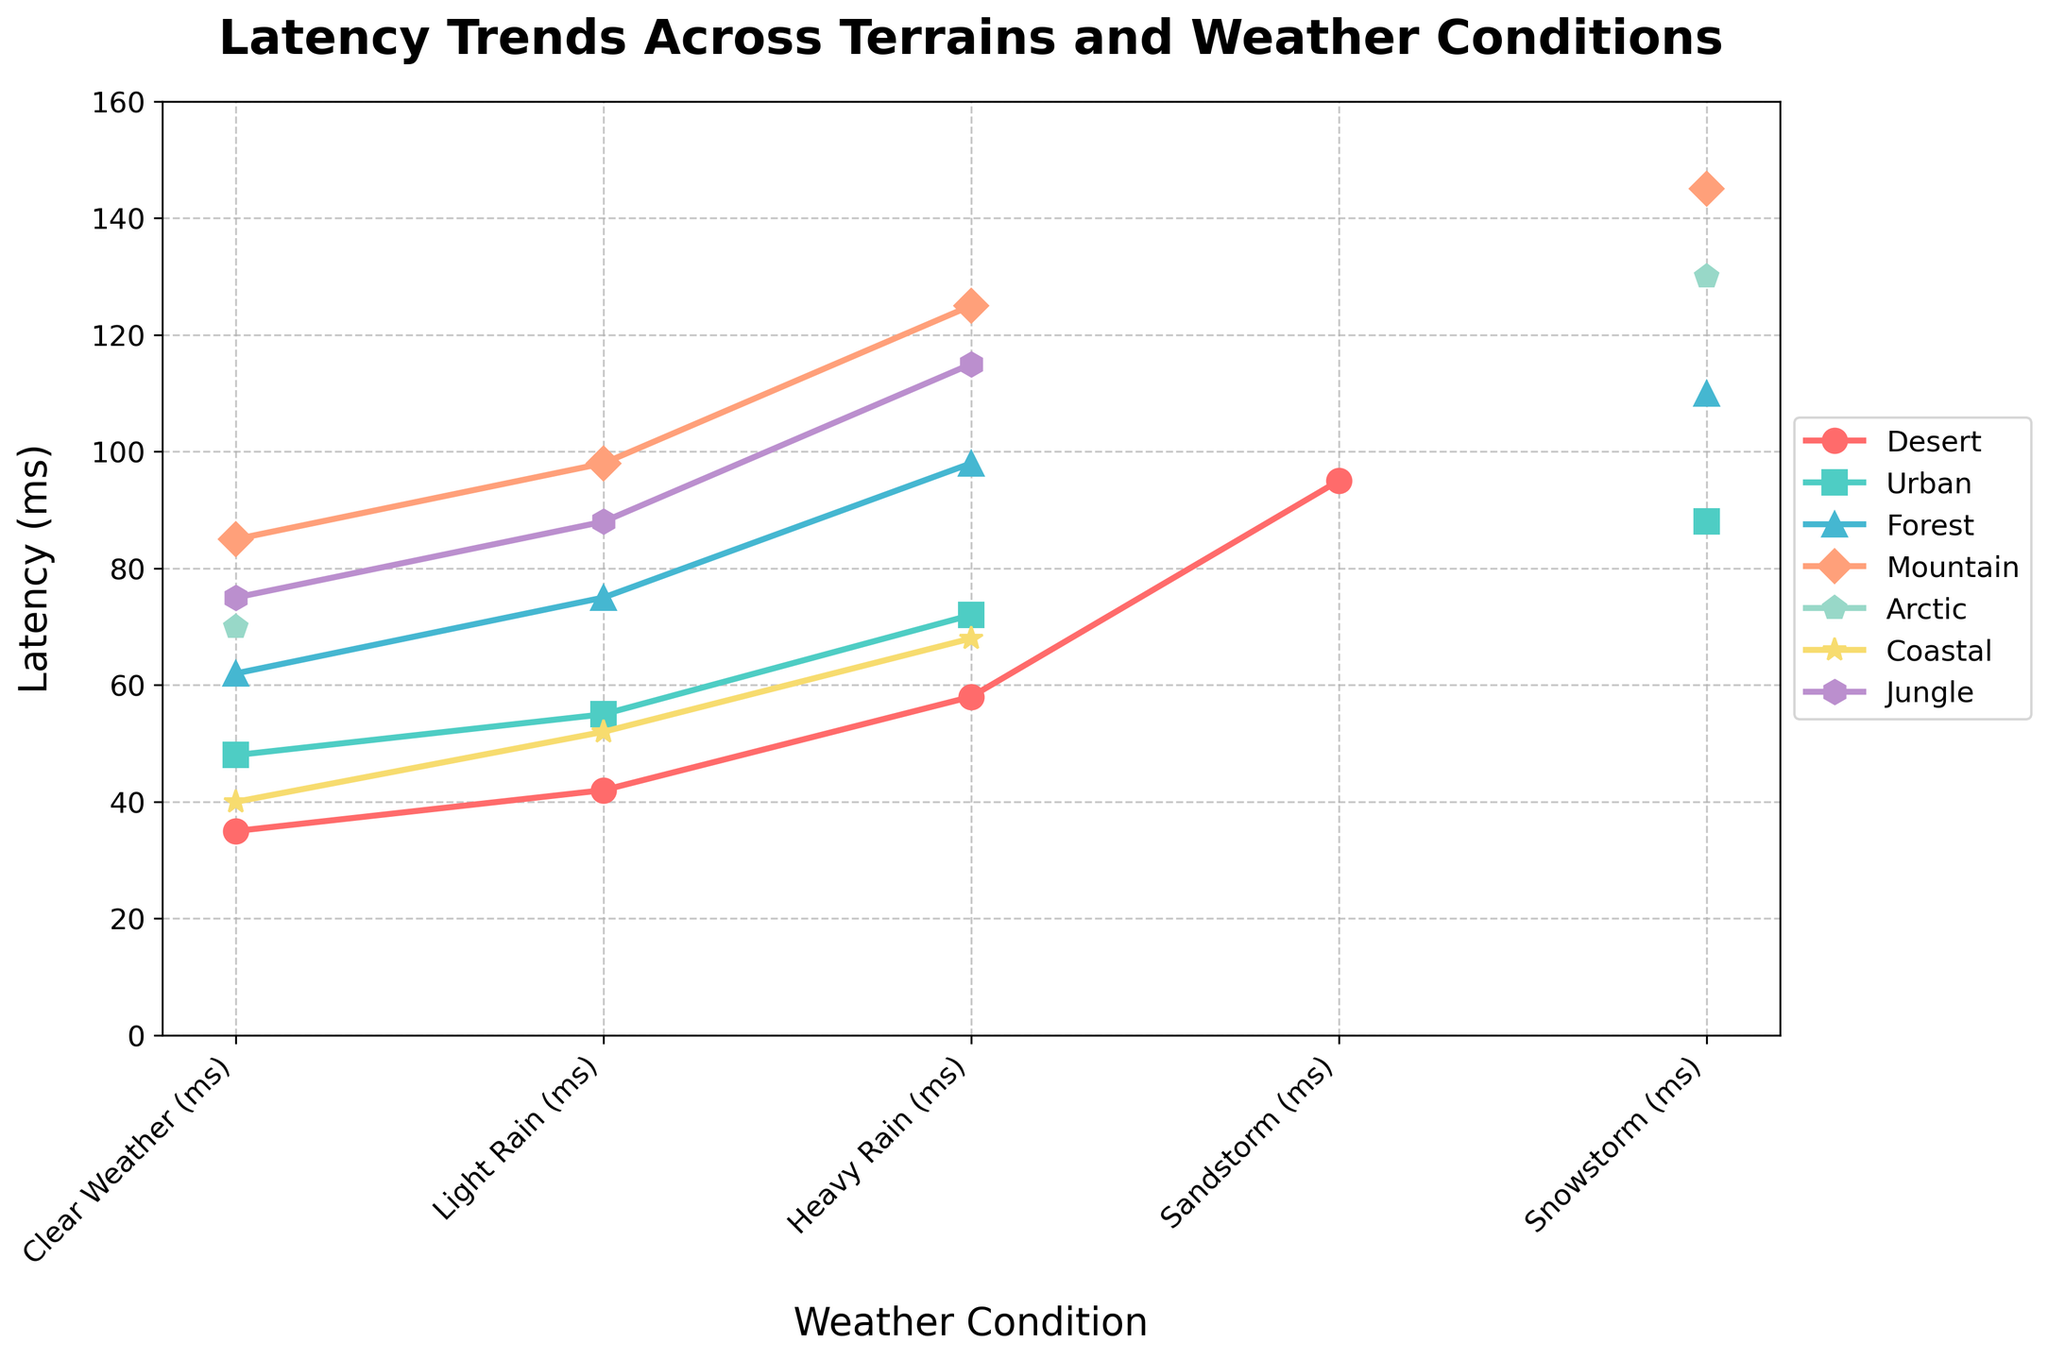What is the average latency for the Arctic terrain across all weather conditions? First, look at the latency values for the Arctic terrain in each weather condition: Clear Weather (70 ms) and Snowstorm (130 ms). Note that 'N/A' values should be excluded. The average latency can be calculated by summing these values (70 + 130 = 200) and then dividing by the number of valid entries (2). Therefore, 200/2 = 100 ms
Answer: 100 ms Which terrain has the highest latency in Clear Weather conditions? Observe the latency values in the Clear Weather column. The values are Desert (35 ms), Urban (48 ms), Forest (62 ms), Mountain (85 ms), Arctic (70 ms), Coastal (40 ms), and Jungle (75 ms). The highest latency is in the Mountain terrain with 85 ms
Answer: Mountain How does the latency in Heavy Rain conditions for Urban compare to that for Forest terrain? The latency for Urban in Heavy Rain is 72 ms, and for Forest, it is 98 ms. By comparing these two values, we see that the latency for Urban in Heavy Rain is less than that for Forest (72 < 98)
Answer: Urban has less latency Which terrain experiences the greatest increase in latency from Clear Weather to Heavy Rain conditions? Calculate the difference between latency in Clear Weather and Heavy Rain for each terrain where both values are available: Desert (58-35=23), Urban (72-48=24), Forest (98-62=36), Coastal (68-40=28), Jungle (115-75=40). The greatest increase is in Jungle with an increase of 40 ms
Answer: Jungle What is the total latency summed across all terrains for Light Rain conditions? Sum the latencies for each terrain in Light Rain: Desert (42 ms), Urban (55 ms), Forest (75 ms), Mountain (98 ms), Coastal (52 ms), Jungle (88 ms). Total = 42 + 55 + 75 + 98 + 52 + 88 = 410 ms
Answer: 410 ms In which terrain is the latency for Snowstorm conditions highest? The latencies for Snowstorm conditions are: Urban (88 ms), Forest (110 ms), Mountain (145 ms), Arctic (130 ms). The highest latency is in Mountain terrain with 145 ms
Answer: Mountain Which two terrains have the most similar latency values in Light Rain conditions? The latencies for Light Rain are: Desert (42 ms), Urban (55 ms), Forest (75 ms), Mountain (98 ms), Coastal (52 ms), Jungle (88 ms). The most similar values are Desert (42 ms) and Coastal (52 ms), with a difference of 10 ms
Answer: Desert and Coastal What is the difference in latency between Clear Weather and Sandstorm conditions for the Desert terrain? The latency for Desert in Clear Weather is 35 ms, and in Sandstorm it is 95 ms. The difference is 95 - 35 = 60 ms
Answer: 60 ms What is the average latency for Coastal terrain across the available weather conditions? First, note the available latency values for Coastal terrain: Clear Weather (40 ms), Light Rain (52 ms), and Heavy Rain (68 ms). The average can be calculated by summing these values (40 + 52 + 68 = 160) and then dividing by the number of valid entries (3). Therefore, 160/3 ≈ 53.33 ms
Answer: 53.33 ms 